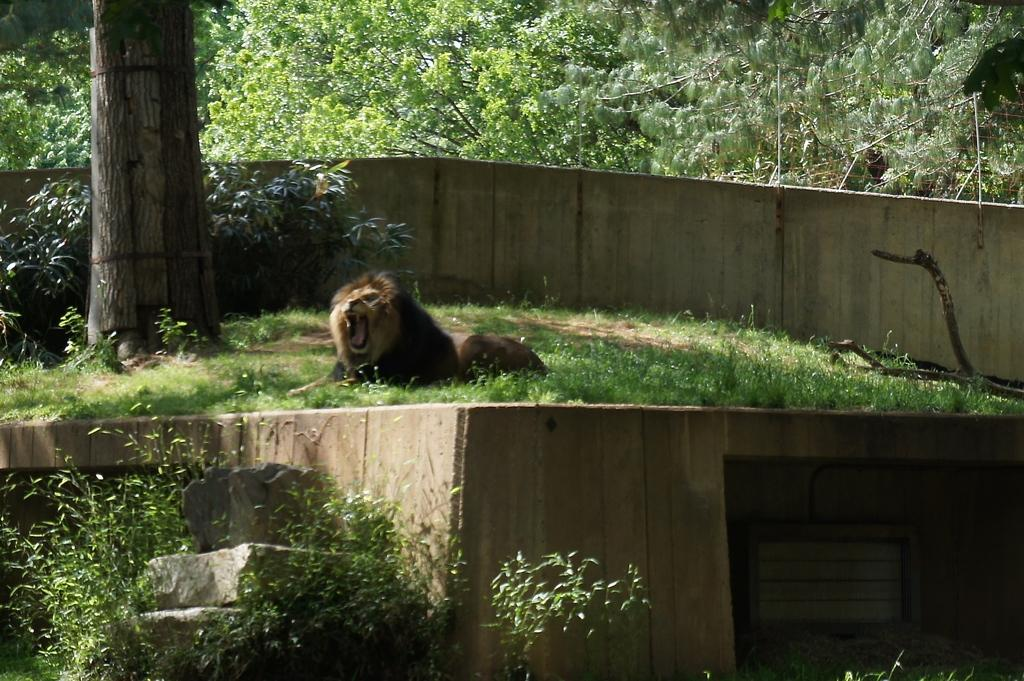What animal is on the ground in the image? There is a lion on the ground in the image. What else can be seen on the ground in the image? There are plants and trees on the ground in the image. What type of boundary is visible in the image? The image shows a boundary. What can be seen in the background of the image? There are trees visible in the background of the image. Can you tell me how many basketballs are visible in the image? There are no basketballs present in the image. What type of trail can be seen in the image? There is no trail visible in the image. 